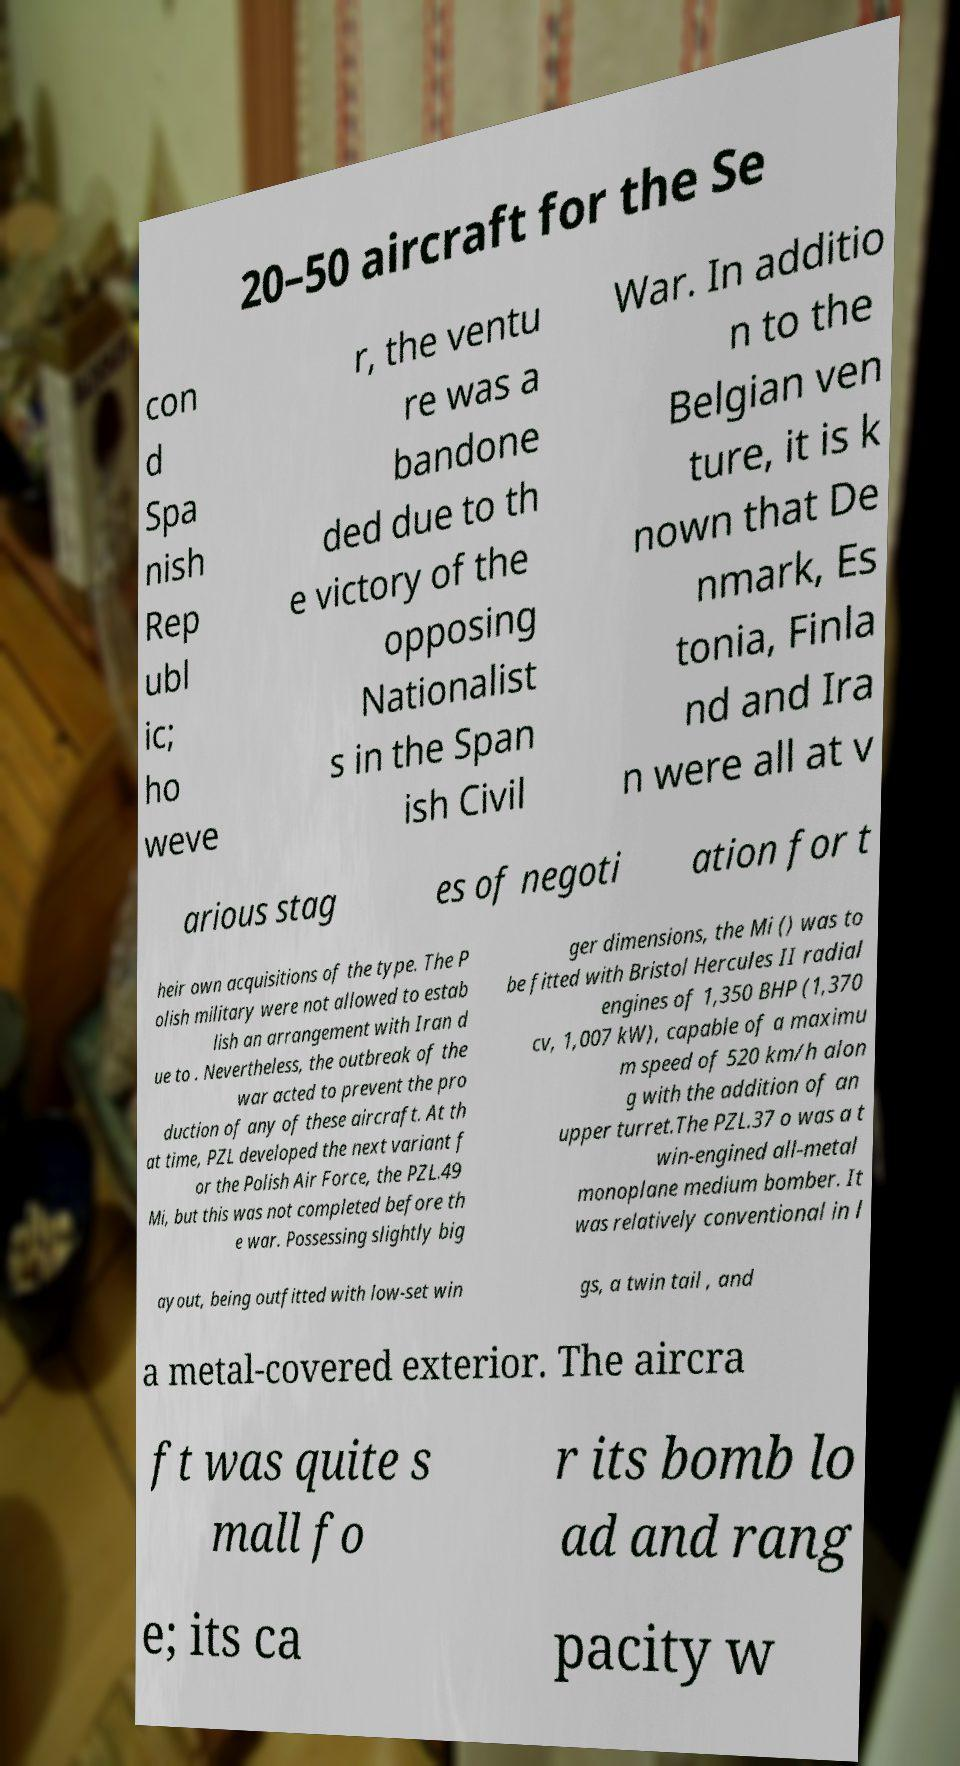There's text embedded in this image that I need extracted. Can you transcribe it verbatim? 20–50 aircraft for the Se con d Spa nish Rep ubl ic; ho weve r, the ventu re was a bandone ded due to th e victory of the opposing Nationalist s in the Span ish Civil War. In additio n to the Belgian ven ture, it is k nown that De nmark, Es tonia, Finla nd and Ira n were all at v arious stag es of negoti ation for t heir own acquisitions of the type. The P olish military were not allowed to estab lish an arrangement with Iran d ue to . Nevertheless, the outbreak of the war acted to prevent the pro duction of any of these aircraft. At th at time, PZL developed the next variant f or the Polish Air Force, the PZL.49 Mi, but this was not completed before th e war. Possessing slightly big ger dimensions, the Mi () was to be fitted with Bristol Hercules II radial engines of 1,350 BHP (1,370 cv, 1,007 kW), capable of a maximu m speed of 520 km/h alon g with the addition of an upper turret.The PZL.37 o was a t win-engined all-metal monoplane medium bomber. It was relatively conventional in l ayout, being outfitted with low-set win gs, a twin tail , and a metal-covered exterior. The aircra ft was quite s mall fo r its bomb lo ad and rang e; its ca pacity w 